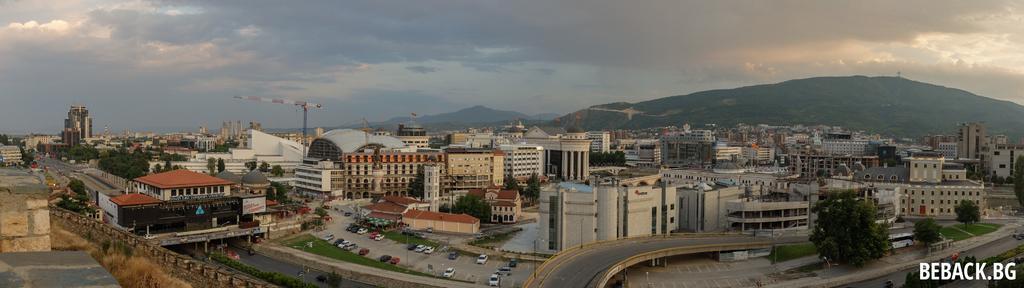Can you describe this image briefly? This picture is clicked outside the city. At the bottom of the picture, we see the road, bridge and cars parked on the road. Beside that, we see the grass and street lights. On the left side, we see a building and a wall which is made up of stones. There are buildings and trees in the background. We even see a tower. There are trees and hills in the background. On the right side, we see the road, street lights and trees. At the top, we see the sky and the clouds. 